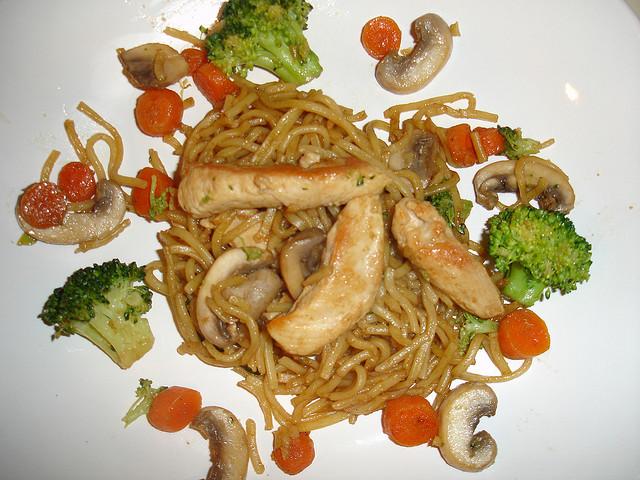How many piece of broccoli?
Answer briefly. 3. What are the red food items?
Be succinct. Carrots. What meat is in the dish?
Give a very brief answer. Chicken. 